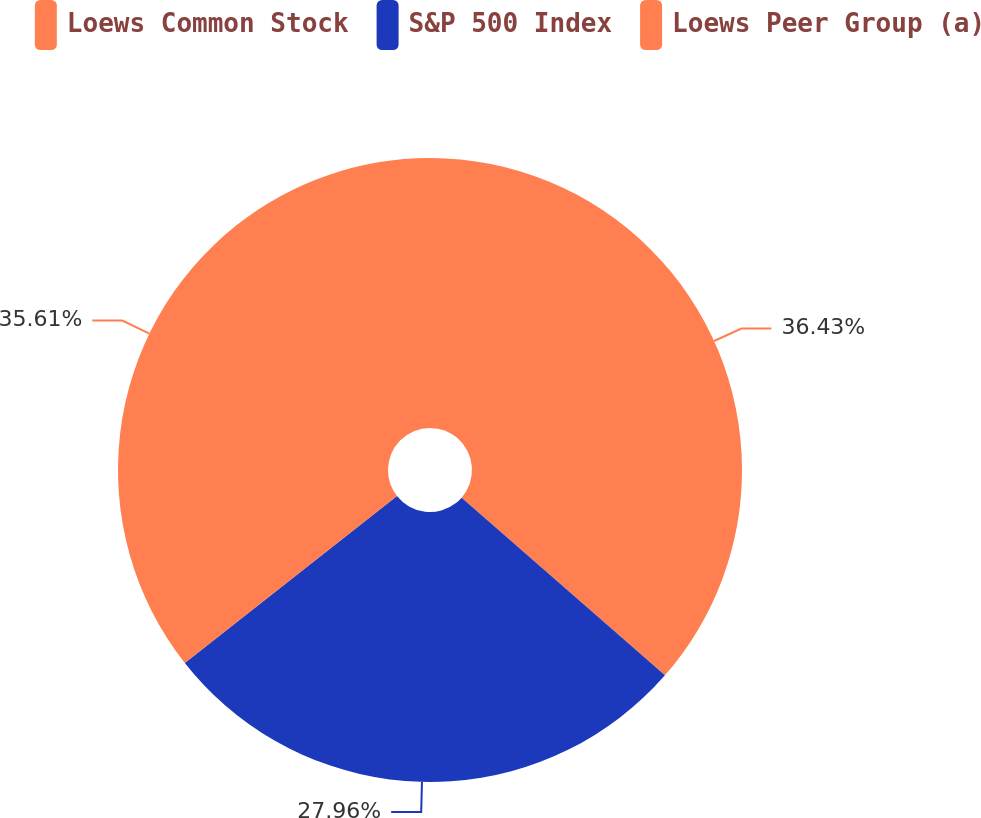Convert chart to OTSL. <chart><loc_0><loc_0><loc_500><loc_500><pie_chart><fcel>Loews Common Stock<fcel>S&P 500 Index<fcel>Loews Peer Group (a)<nl><fcel>36.43%<fcel>27.96%<fcel>35.61%<nl></chart> 